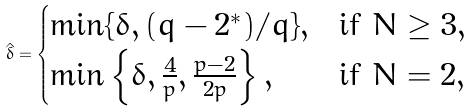Convert formula to latex. <formula><loc_0><loc_0><loc_500><loc_500>\hat { \delta } = \begin{cases} \min \{ \delta , ( q - 2 ^ { * } ) / q \} , & \text {if } N \geq 3 , \\ \min \left \{ \delta , \frac { 4 } { p } , \frac { p - 2 } { 2 p } \right \} , & \text {if } N = 2 , \end{cases}</formula> 